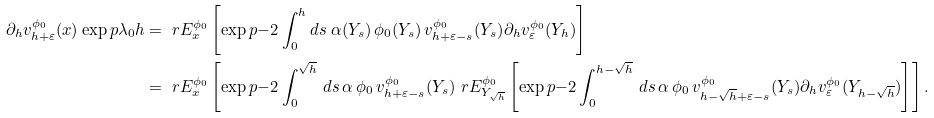<formula> <loc_0><loc_0><loc_500><loc_500>\partial _ { h } v _ { h + \varepsilon } ^ { \phi _ { 0 } } ( x ) \exp p { \lambda _ { 0 } h } & = \ r E ^ { \phi _ { 0 } } _ { x } \left [ \exp p { - 2 \int _ { 0 } ^ { h } d s \ \alpha ( Y _ { s } ) \, \phi _ { 0 } ( Y _ { s } ) \, v ^ { \phi _ { 0 } } _ { h + \varepsilon - s } ( Y _ { s } ) } \partial _ { h } v _ { \varepsilon } ^ { \phi _ { 0 } } ( Y _ { h } ) \right ] \\ & = \ r E ^ { \phi _ { 0 } } _ { x } \left [ \exp p { - 2 \int _ { 0 } ^ { \sqrt { h } } \, d s \, \alpha \, \phi _ { 0 } \, v ^ { \phi _ { 0 } } _ { h + \varepsilon - s } ( Y _ { s } ) } \ r E ^ { \phi _ { 0 } } _ { Y _ { \sqrt { h } } } \left [ \exp p { - 2 \int _ { 0 } ^ { h - \sqrt { h } } \, d s \, \alpha \, \phi _ { 0 } \, v ^ { \phi _ { 0 } } _ { h - \sqrt { h } + \varepsilon - s } ( Y _ { s } ) } \partial _ { h } v _ { \varepsilon } ^ { \phi _ { 0 } } ( { Y } _ { h - \sqrt { h } } ) \right ] \right ] .</formula> 